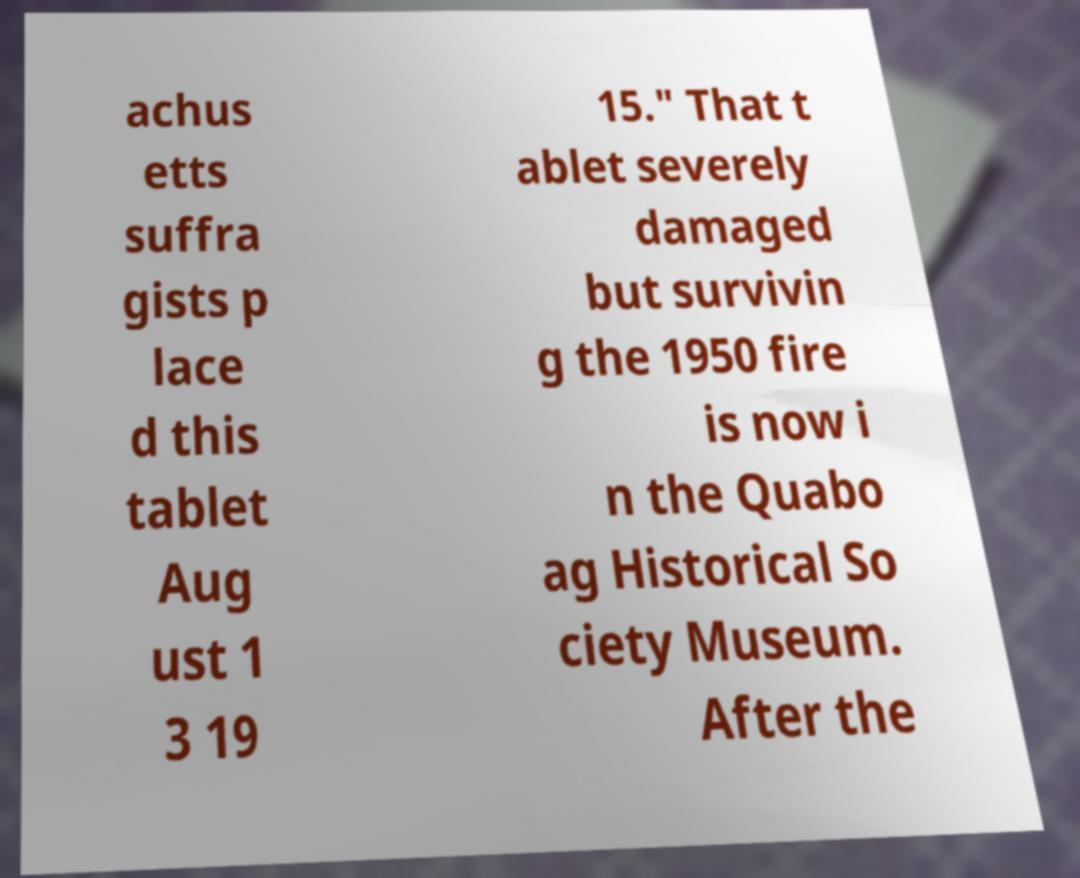Could you extract and type out the text from this image? achus etts suffra gists p lace d this tablet Aug ust 1 3 19 15." That t ablet severely damaged but survivin g the 1950 fire is now i n the Quabo ag Historical So ciety Museum. After the 